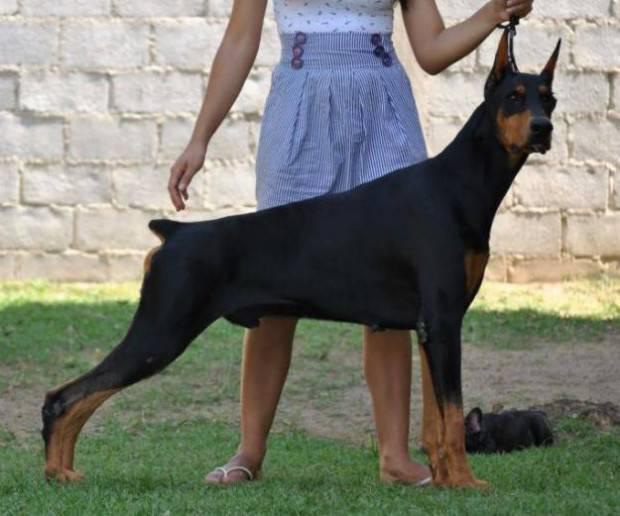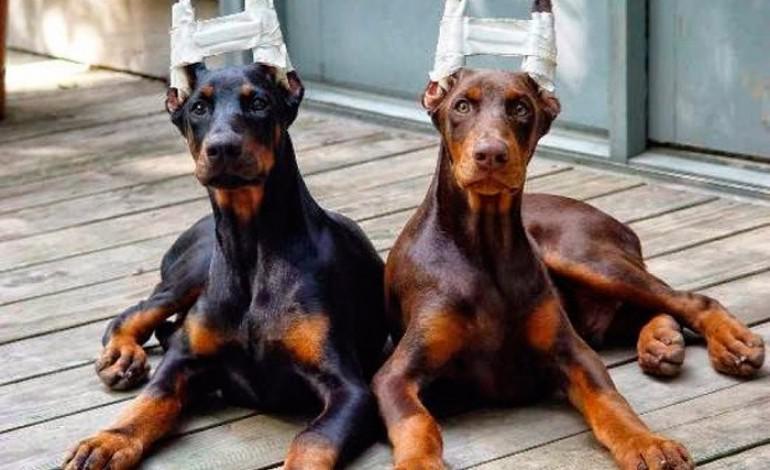The first image is the image on the left, the second image is the image on the right. Assess this claim about the two images: "At least one doberman has its tongue out.". Correct or not? Answer yes or no. No. 